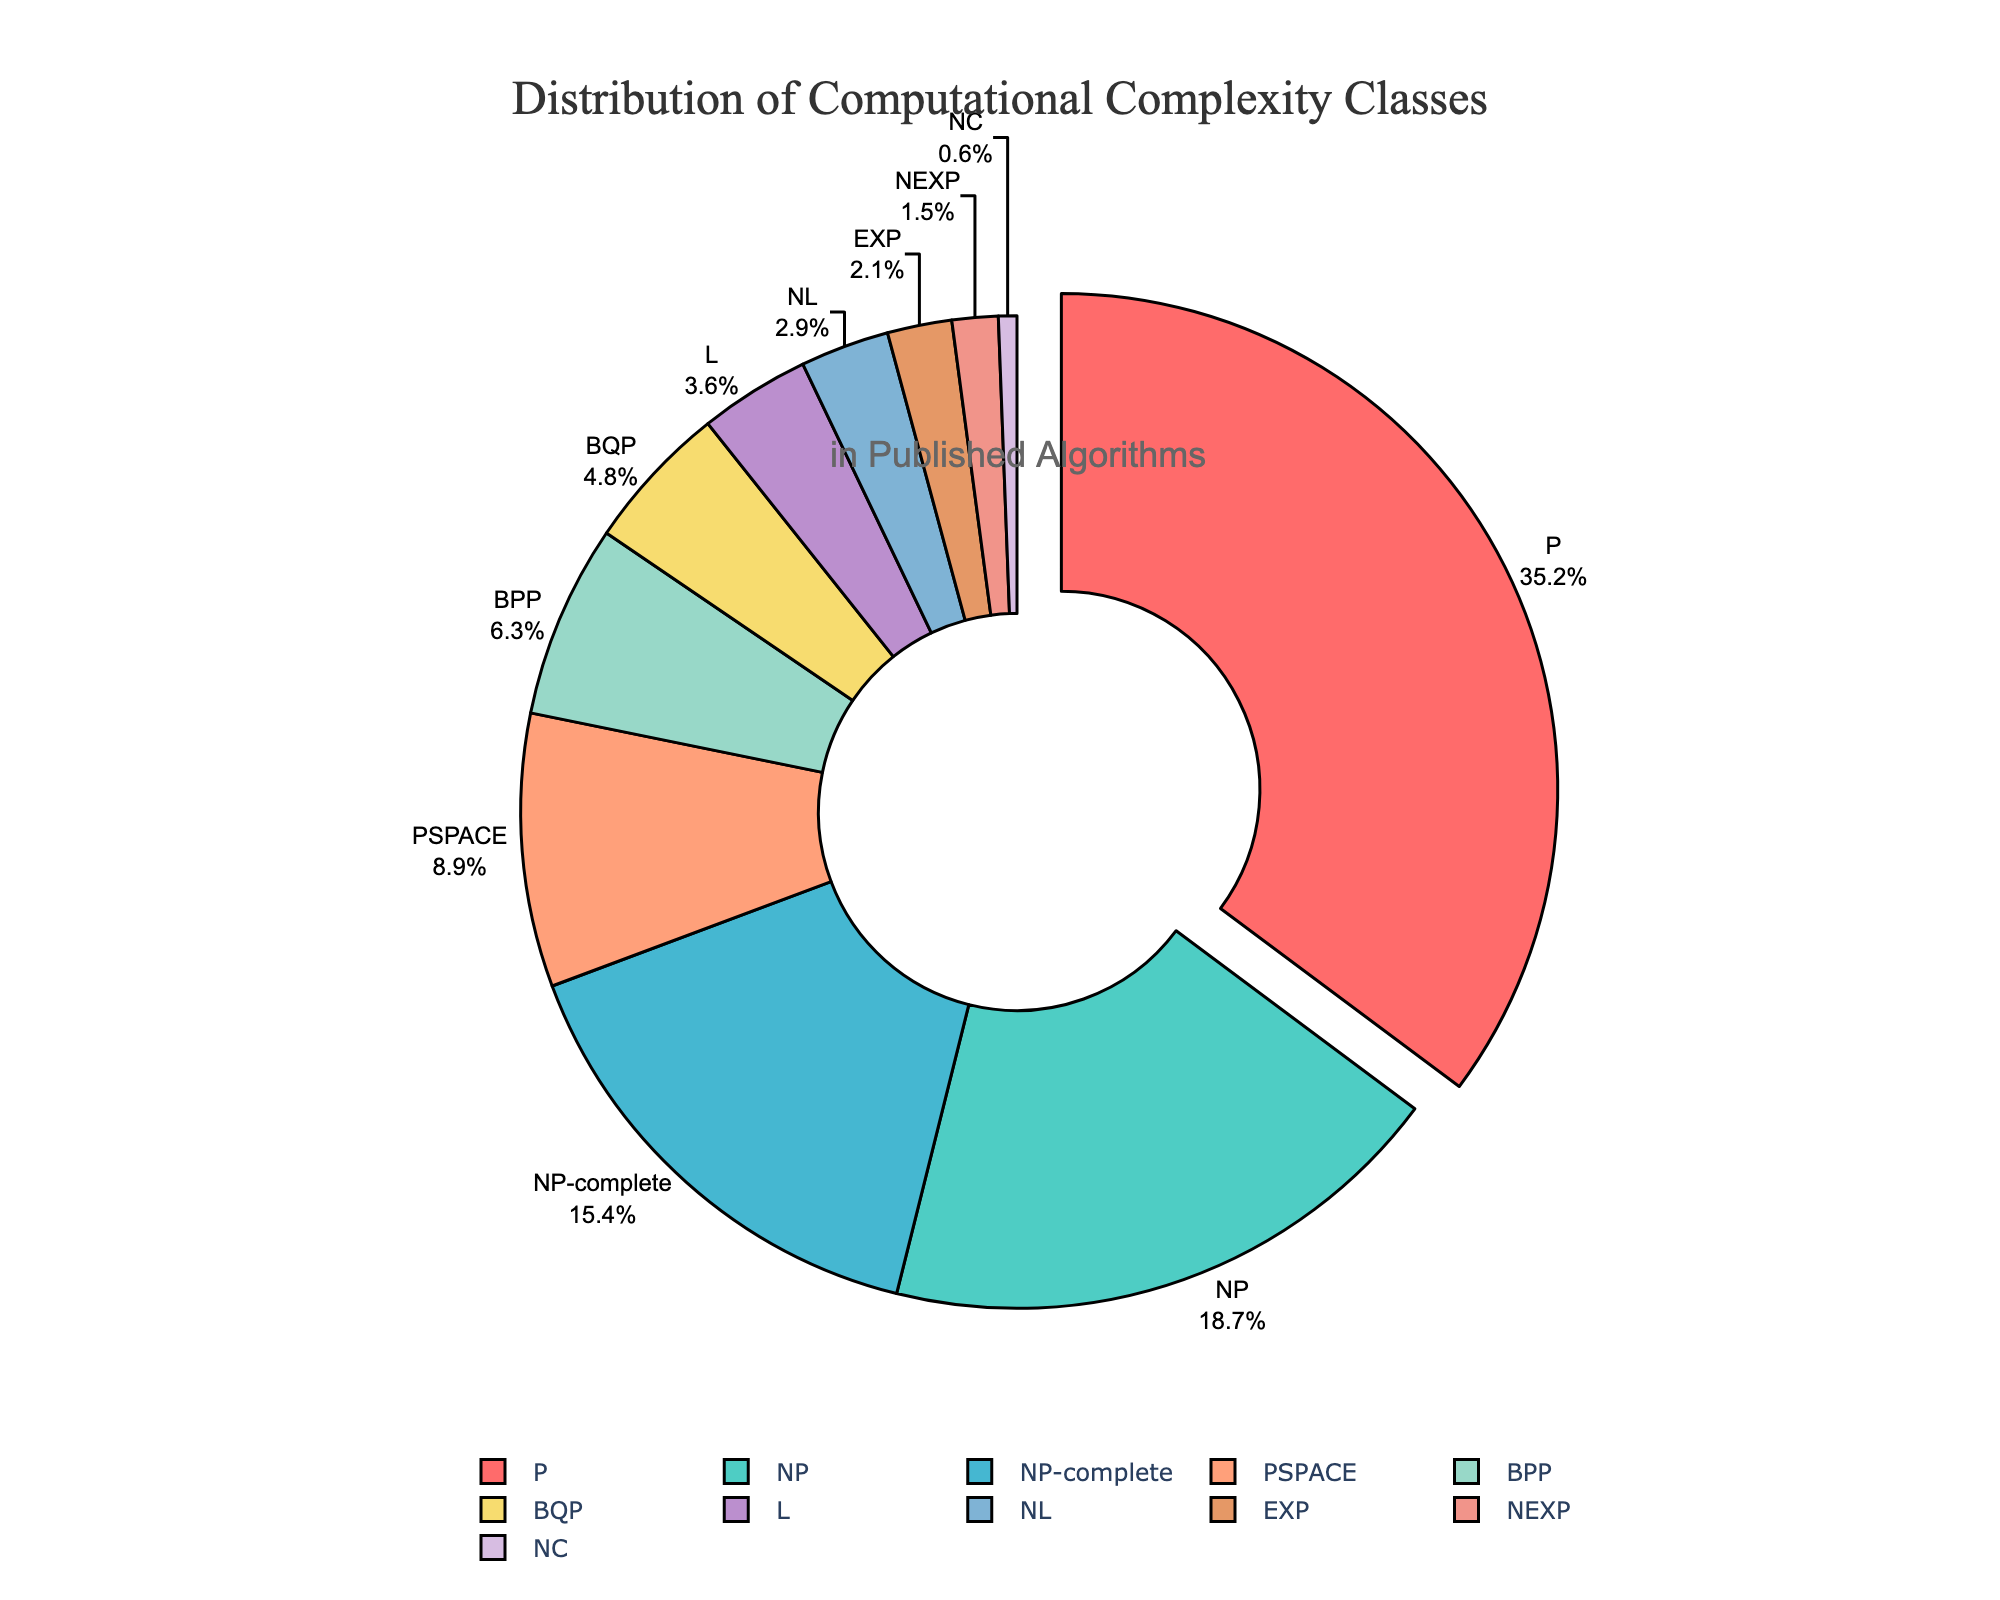Which complexity class has the highest percentage in the distribution? The complexity class with the highest percentage is identified by looking at the portion of the pie chart that is slightly pulled out. This is the portion for class 'P' with 35.2%.
Answer: P What is the combined percentage of NP and NP-complete classes? To find the combined percentage of NP and NP-complete, add their respective percentages: 18.7 (NP) + 15.4 (NP-complete) = 34.1%.
Answer: 34.1% Is the percentage of PSPACE classes greater than that of BPP classes? Compare the percentages of PSPACE (8.9%) and BPP (6.3%). Since 8.9% is greater than 6.3%, the answer is yes.
Answer: Yes Out of classes NC and NEXP, which one has a higher representation and by what percentage? NEXP has a percentage of 1.5% while NC has 0.6%. Subtract NC's percentage from NEXP's: 1.5% - 0.6% = 0.9%. Thus, NEXP has a higher representation by 0.9%.
Answer: NEXP, 0.9% Which class occupies almost double the percentage of BQP? To find which class is nearly double BQP's percentage of 4.8%, we check L with 3.6% which is lesser, but PSPACE with 8.9% is almost double 4.8%.
Answer: PSPACE What is the total percentage of classes L, NL, and NC combined? The percentages are L (3.6%), NL (2.9%), and NC (0.6%). Sum these percentages: 3.6 + 2.9 + 0.6 = 7.1%.
Answer: 7.1% Which class has the smallest representation? Identify the smallest section in the pie chart which corresponds to NC with 0.6%.
Answer: NC How much more represented is P compared to the second most represented class? P is 35.2%; the second most is NP with 18.7%. Subtract NP from P: 35.2% - 18.7% = 16.5%.
Answer: 16.5% Does the total percentage of NP and NP-complete exceed that of P? NP and NP-complete together are 34.1%, while P alone is 35.2%. Compare these sum percentages to find 34.1% < 35.2%, so the total does not exceed P.
Answer: No Is the percentage for class EXP less than half of the percentage for NP-complete? EXP is 2.1%, and half of NP-complete's 15.4% is 15.4 / 2 = 7.7%. Since 2.1 < 7.7%, EXP is less than half of NP-complete's percentage.
Answer: Yes 